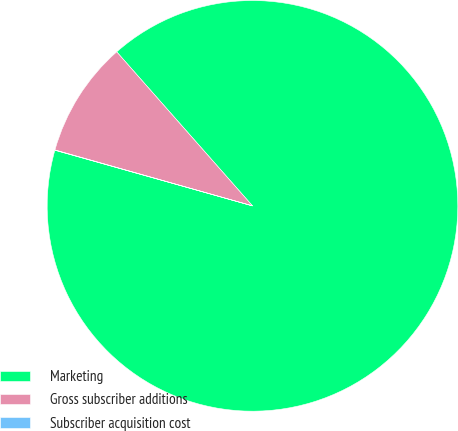Convert chart to OTSL. <chart><loc_0><loc_0><loc_500><loc_500><pie_chart><fcel>Marketing<fcel>Gross subscriber additions<fcel>Subscriber acquisition cost<nl><fcel>90.87%<fcel>9.11%<fcel>0.02%<nl></chart> 